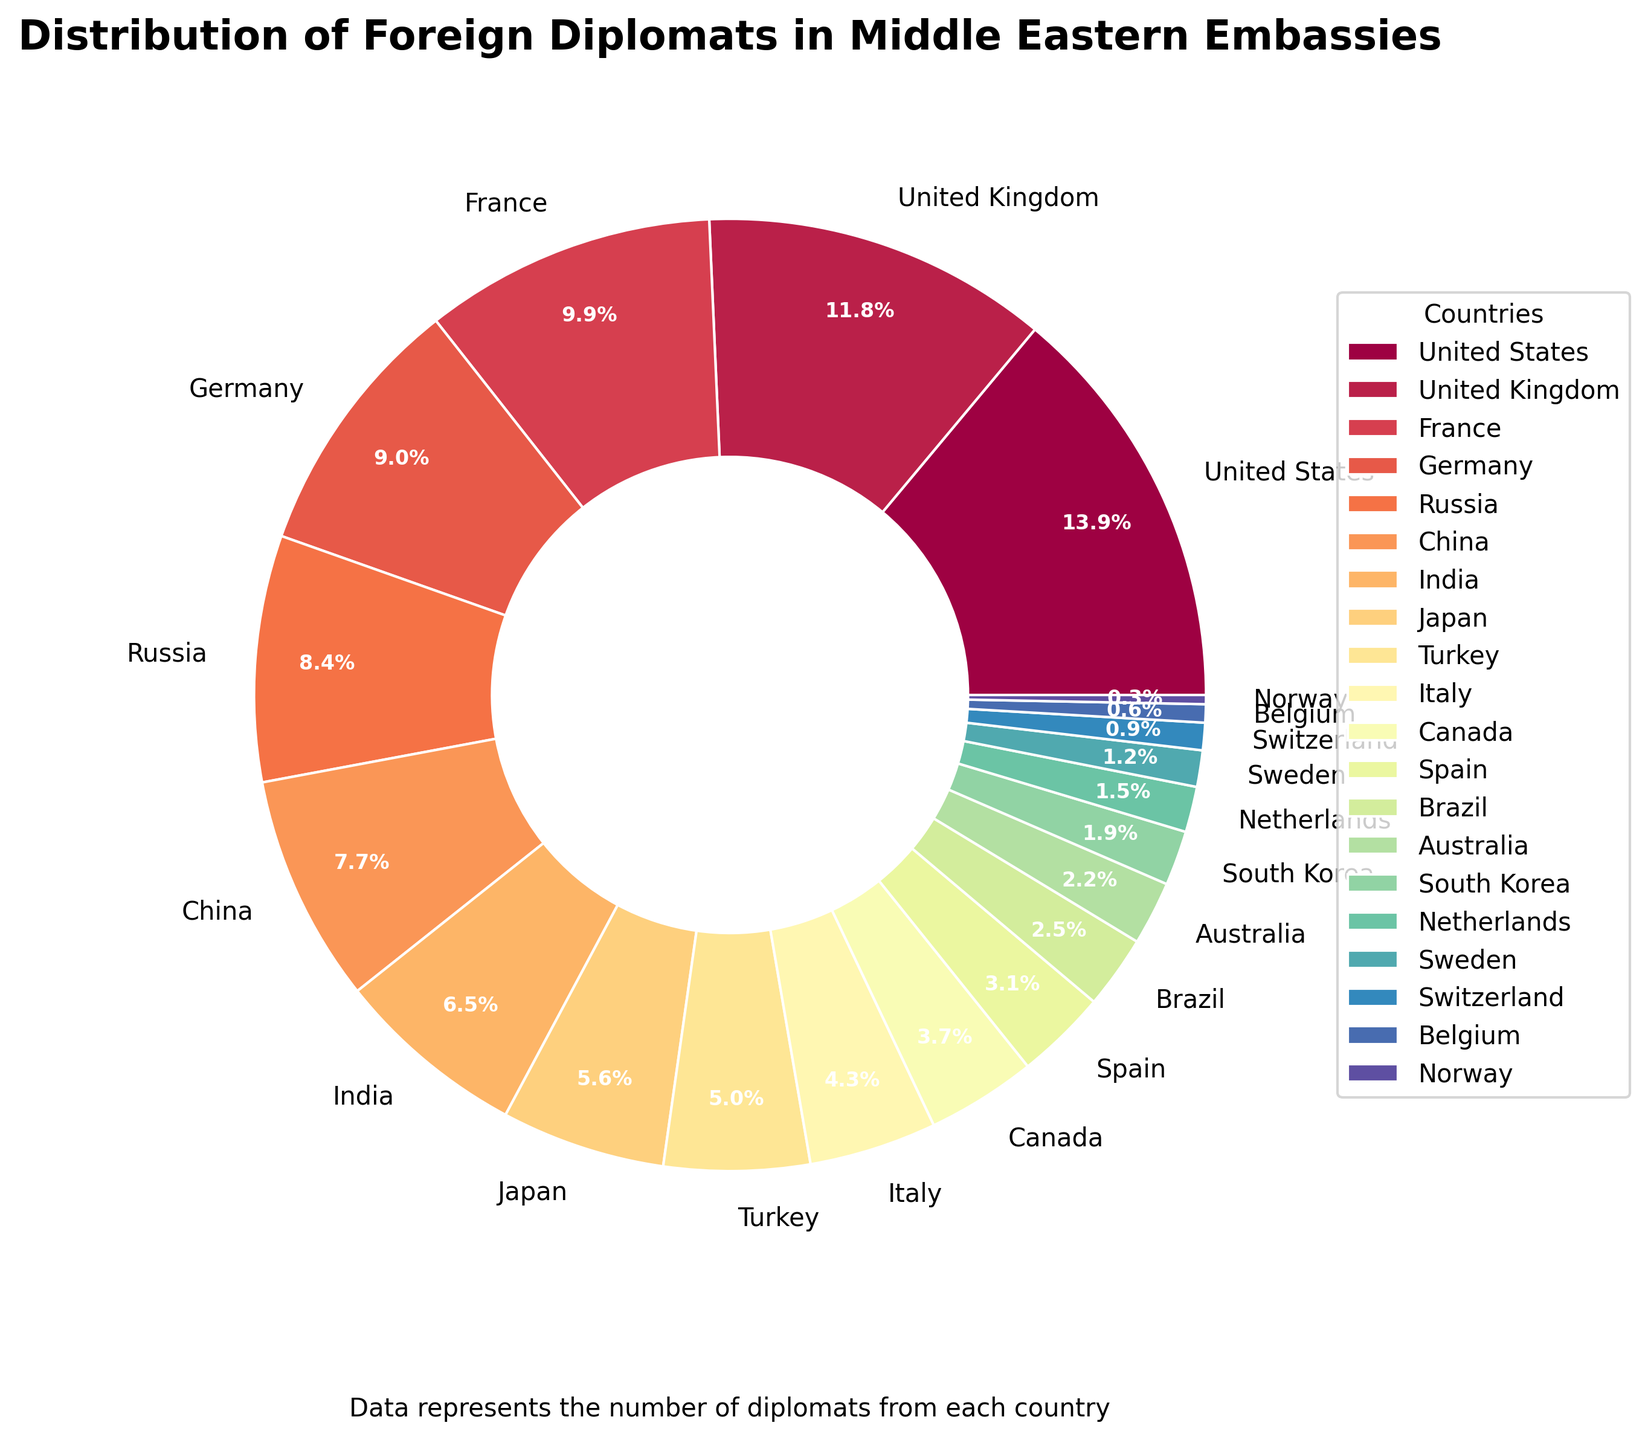Which country has the highest number of diplomats? The largest wedge on the pie chart represents the United States, indicating that it has the highest number of diplomats.
Answer: United States Which two countries have the smallest number of diplomats, and what is their combined percentage? The smallest wedges on the pie chart represent Norway and Belgium. Norway has 1 diplomat, and Belgium has 2 diplomats. Combined, they occupy a very small percentage of the pie chart. Summing their percentages gives around 0.6% + 1.2% = 1.8%.
Answer: Norway and Belgium, 1.8% How many more diplomats does the United States have compared to France? The wedge representing the United States has 45 diplomats, while France has 32 diplomats. The difference is 45 - 32.
Answer: 13 Which country has a slightly larger number of diplomats: Italy or Canada? The wedges representing Italy and Canada can be compared visually, with Italy having 14 diplomats and Canada 12 diplomats. Italy has a slightly larger number.
Answer: Italy What is the total percentage of diplomats from China and India combined? The wedges for China and India together form a larger segment. China has 25 diplomats (11.4%), and India has 21 diplomats (9.6%). Combined, their percentage is 11.4% + 9.6% = 21%.
Answer: 21% What is the difference in the percentage of diplomats between Russia and the United Kingdom? The wedge for Russia has 27 diplomats (12.3%) and for the United Kingdom 38 diplomats (17.3%). The percentage difference is 17.3% - 12.3%.
Answer: 5% Which country’s wedge falls directly in the middle in terms of number of diplomats? Observing the wedges, Japan with 18 diplomats seems to be in the middle compared to the rest of the countries.
Answer: Japan If you combine the number of diplomats from Germany, Russia, and China, what total percentage do they represent? Germany has 29 diplomats (13.2%), Russia has 27 diplomats (12.3%), and China has 25 diplomats (11.4%). Summing these percentages gives 13.2% + 12.3% + 11.4% = 36.9%.
Answer: 36.9% Comparing Brazil and Australia, which country has the least diplomats and how many fewer diplomats does that country have? Brazil has 8 diplomats and Australia 7. The difference in the number of diplomats is 8 - 7.
Answer: Australia, 1 